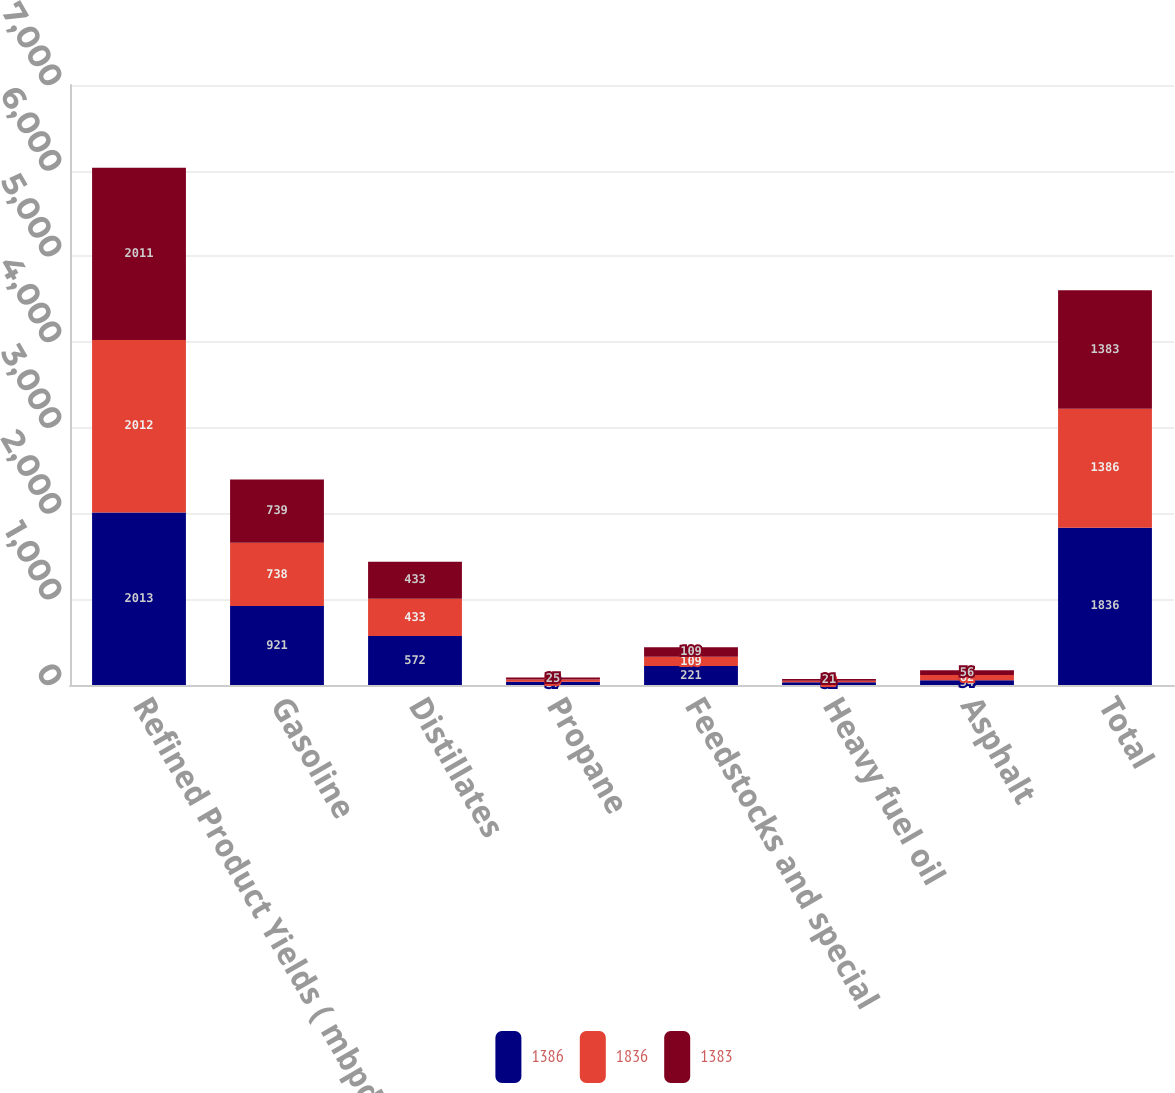Convert chart. <chart><loc_0><loc_0><loc_500><loc_500><stacked_bar_chart><ecel><fcel>Refined Product Yields ( mbpd<fcel>Gasoline<fcel>Distillates<fcel>Propane<fcel>Feedstocks and special<fcel>Heavy fuel oil<fcel>Asphalt<fcel>Total<nl><fcel>1386<fcel>2013<fcel>921<fcel>572<fcel>37<fcel>221<fcel>31<fcel>54<fcel>1836<nl><fcel>1836<fcel>2012<fcel>738<fcel>433<fcel>26<fcel>109<fcel>18<fcel>62<fcel>1386<nl><fcel>1383<fcel>2011<fcel>739<fcel>433<fcel>25<fcel>109<fcel>21<fcel>56<fcel>1383<nl></chart> 